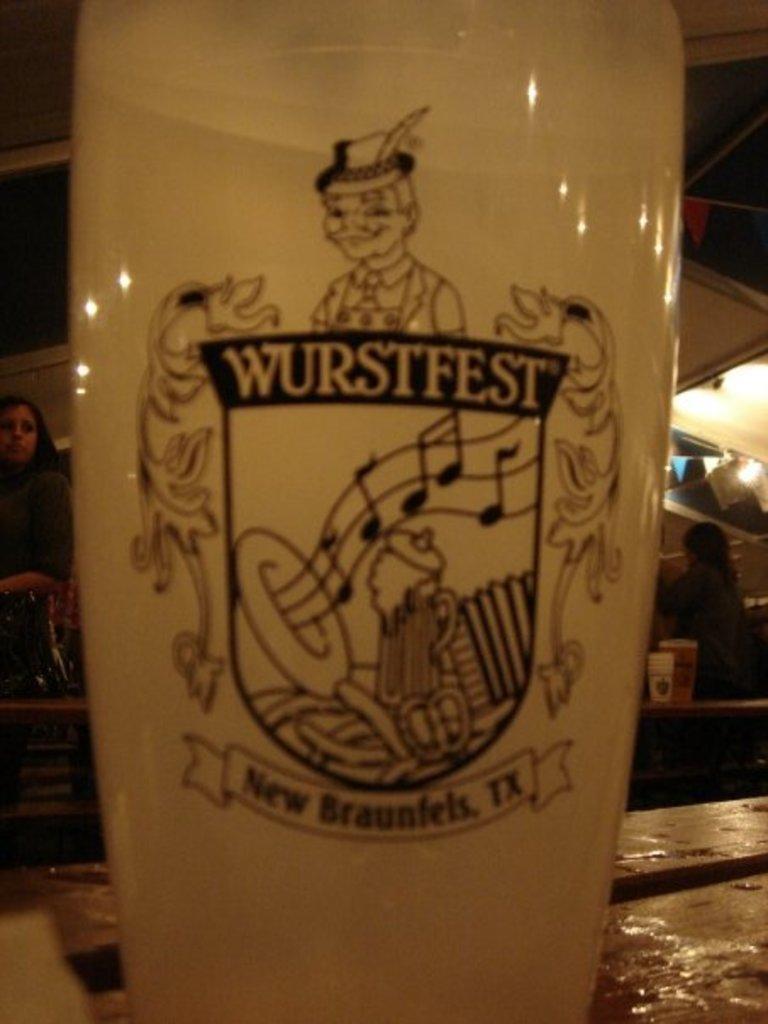In one or two sentences, can you explain what this image depicts? In this image we can see there is the bottle on the table. At the back there are people standing and there are cups and glass. At the top it looks like a roof and there are lights attached to it. 